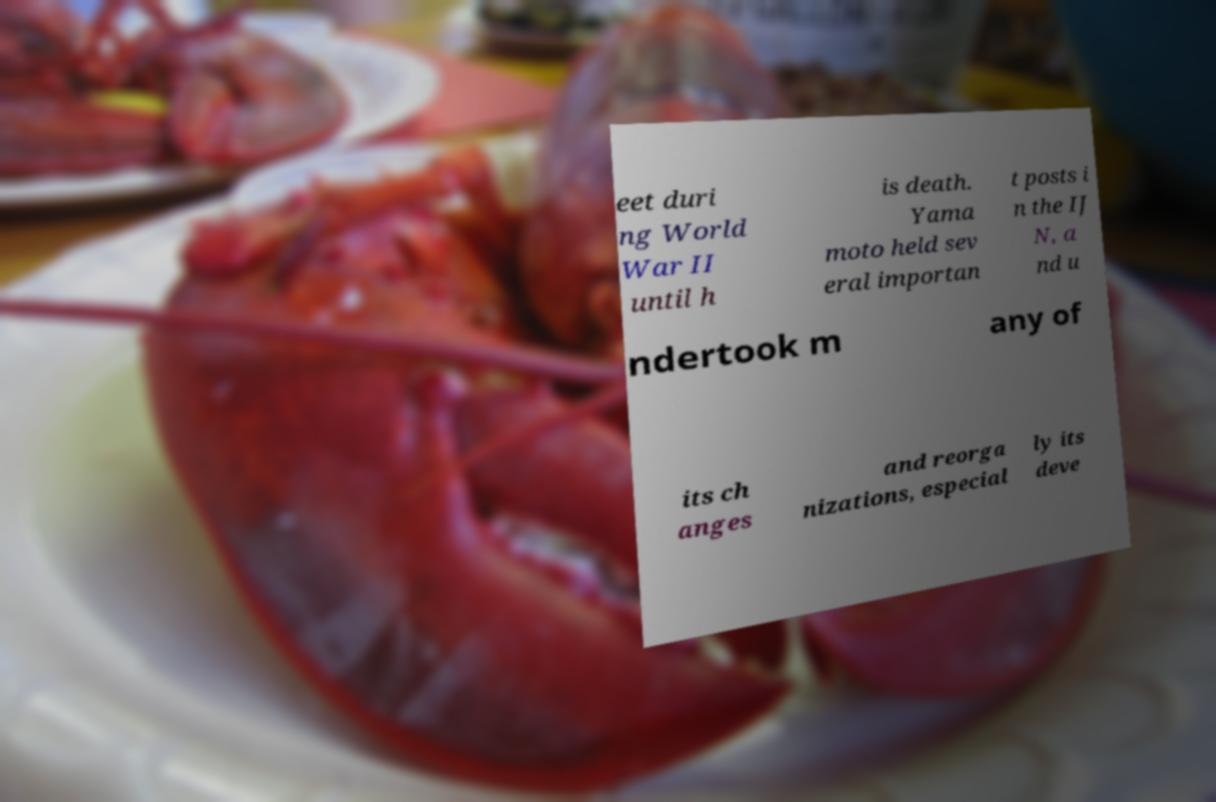Please read and relay the text visible in this image. What does it say? eet duri ng World War II until h is death. Yama moto held sev eral importan t posts i n the IJ N, a nd u ndertook m any of its ch anges and reorga nizations, especial ly its deve 